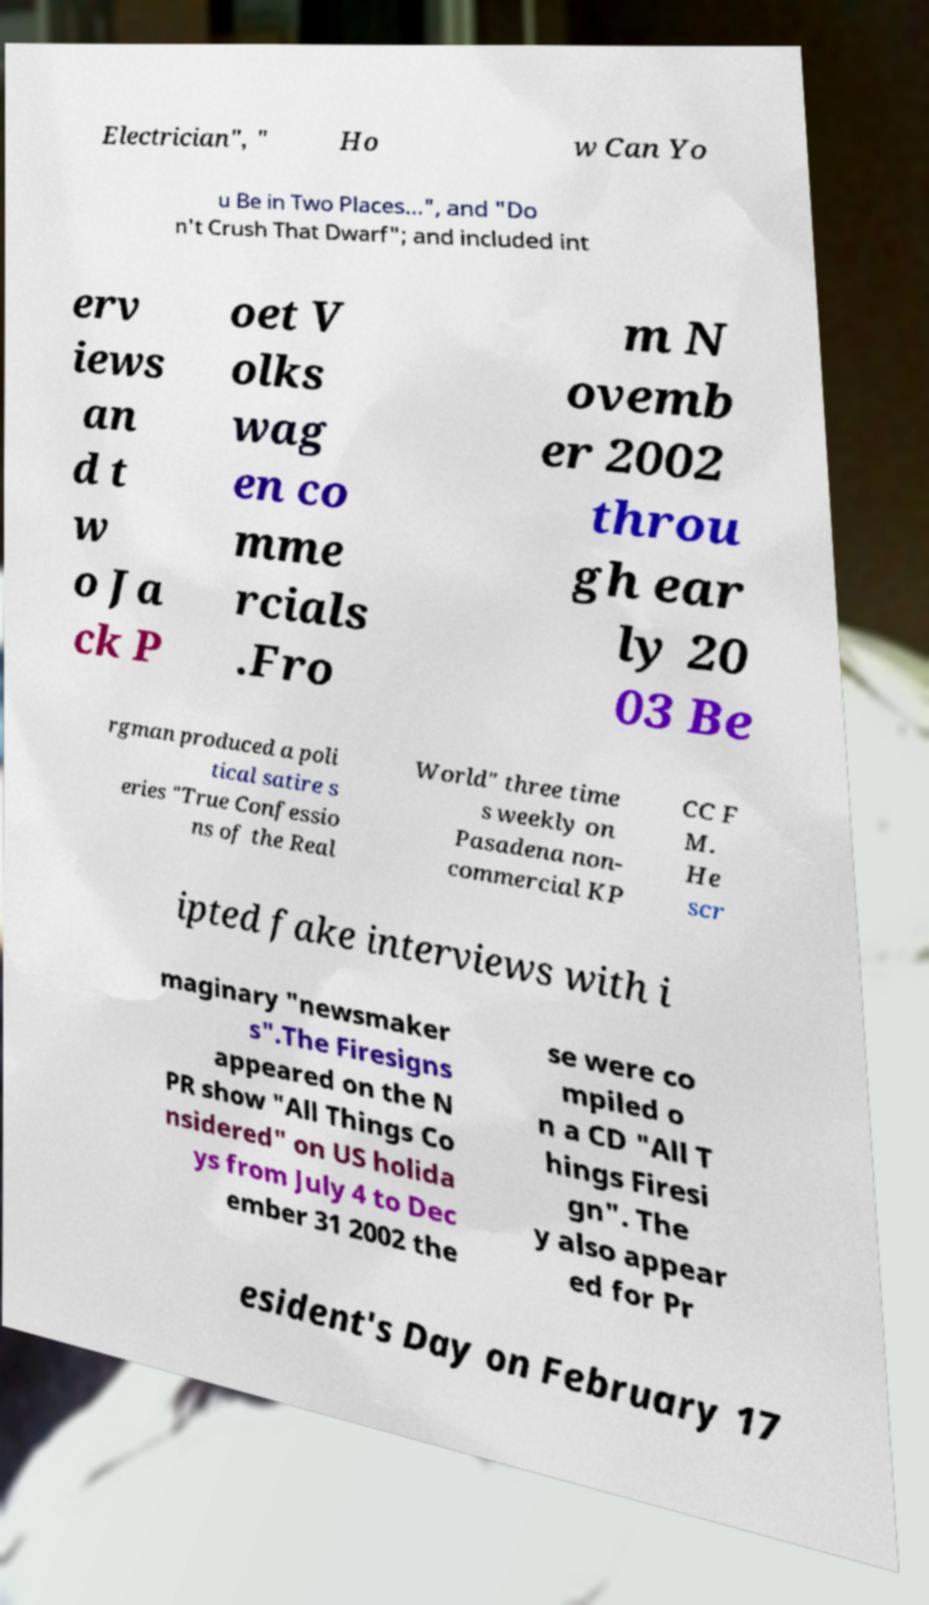There's text embedded in this image that I need extracted. Can you transcribe it verbatim? Electrician", " Ho w Can Yo u Be in Two Places...", and "Do n't Crush That Dwarf"; and included int erv iews an d t w o Ja ck P oet V olks wag en co mme rcials .Fro m N ovemb er 2002 throu gh ear ly 20 03 Be rgman produced a poli tical satire s eries "True Confessio ns of the Real World" three time s weekly on Pasadena non- commercial KP CC F M. He scr ipted fake interviews with i maginary "newsmaker s".The Firesigns appeared on the N PR show "All Things Co nsidered" on US holida ys from July 4 to Dec ember 31 2002 the se were co mpiled o n a CD "All T hings Firesi gn". The y also appear ed for Pr esident's Day on February 17 